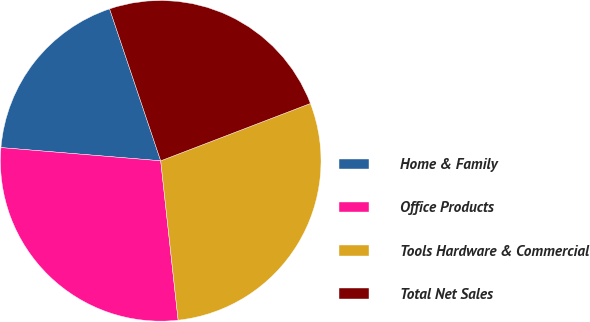<chart> <loc_0><loc_0><loc_500><loc_500><pie_chart><fcel>Home & Family<fcel>Office Products<fcel>Tools Hardware & Commercial<fcel>Total Net Sales<nl><fcel>18.52%<fcel>28.05%<fcel>29.09%<fcel>24.34%<nl></chart> 